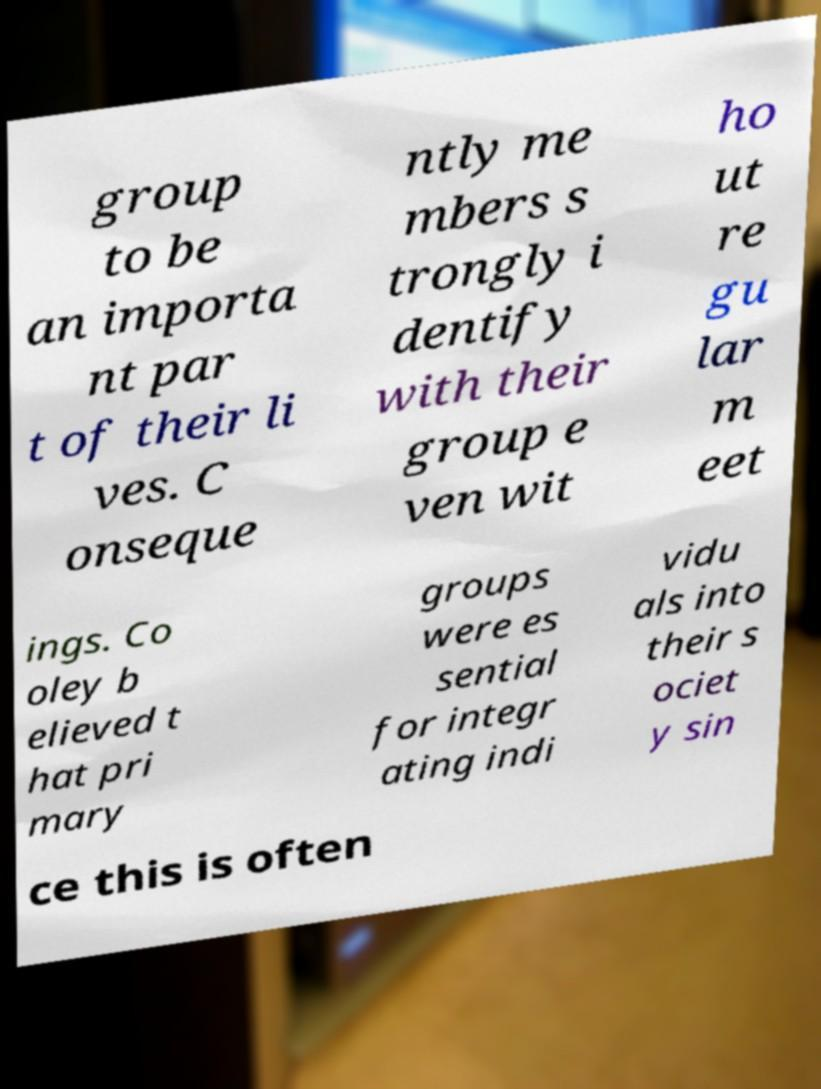I need the written content from this picture converted into text. Can you do that? group to be an importa nt par t of their li ves. C onseque ntly me mbers s trongly i dentify with their group e ven wit ho ut re gu lar m eet ings. Co oley b elieved t hat pri mary groups were es sential for integr ating indi vidu als into their s ociet y sin ce this is often 